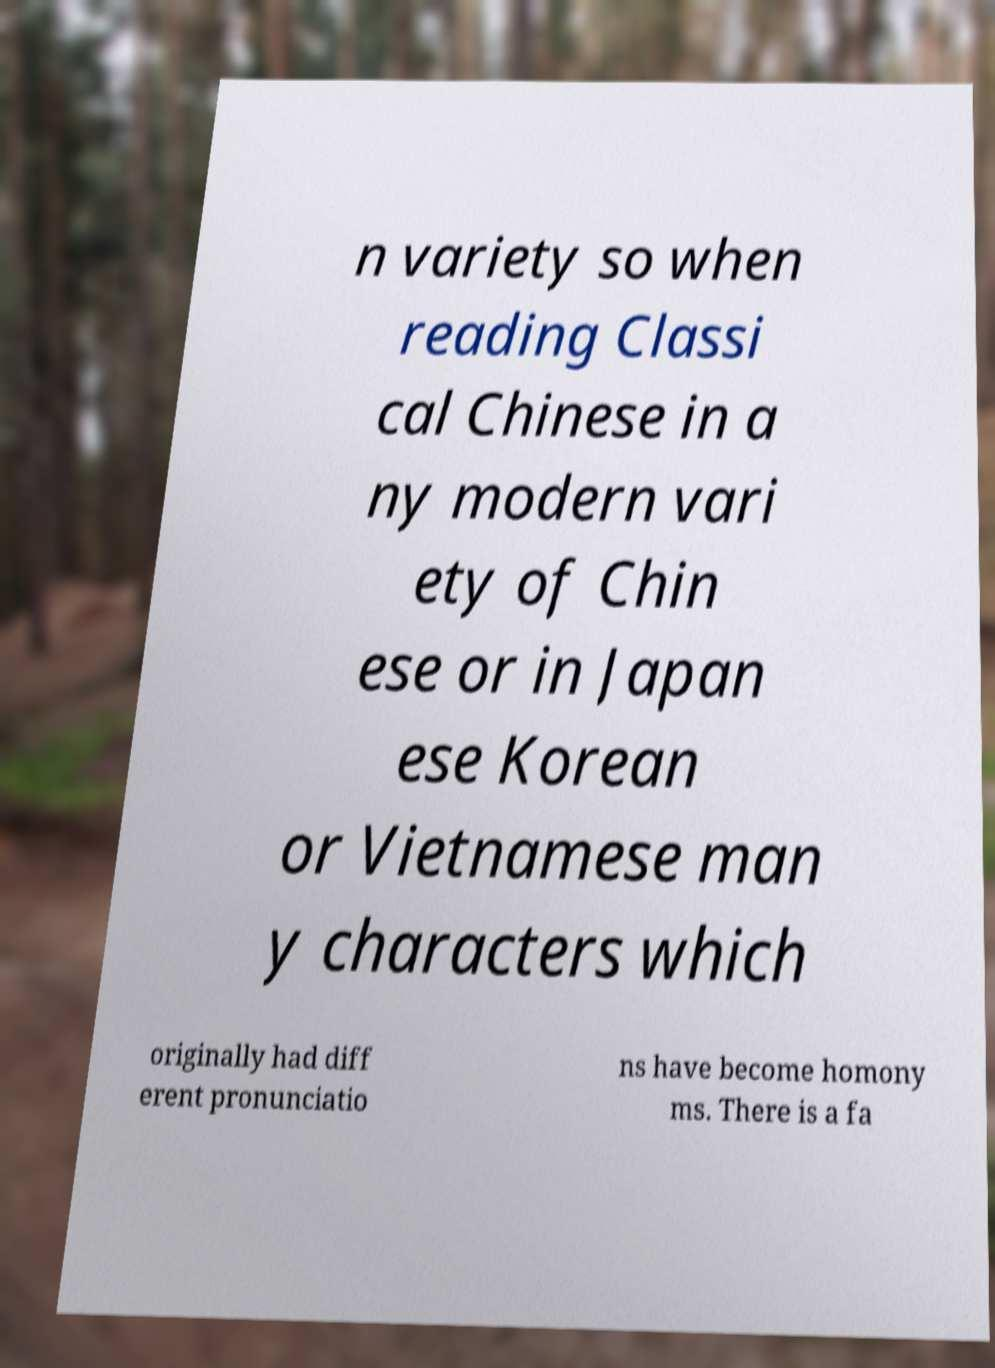Can you read and provide the text displayed in the image?This photo seems to have some interesting text. Can you extract and type it out for me? n variety so when reading Classi cal Chinese in a ny modern vari ety of Chin ese or in Japan ese Korean or Vietnamese man y characters which originally had diff erent pronunciatio ns have become homony ms. There is a fa 